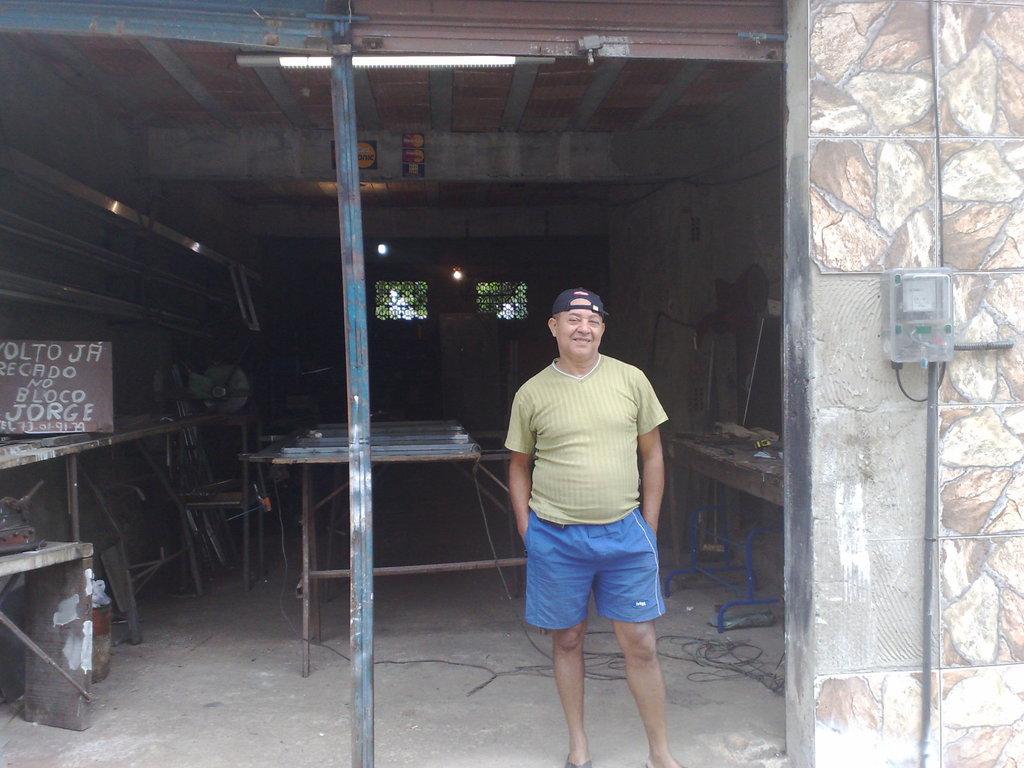What are the last 2 numbers on the sign?
Provide a short and direct response. 79. 